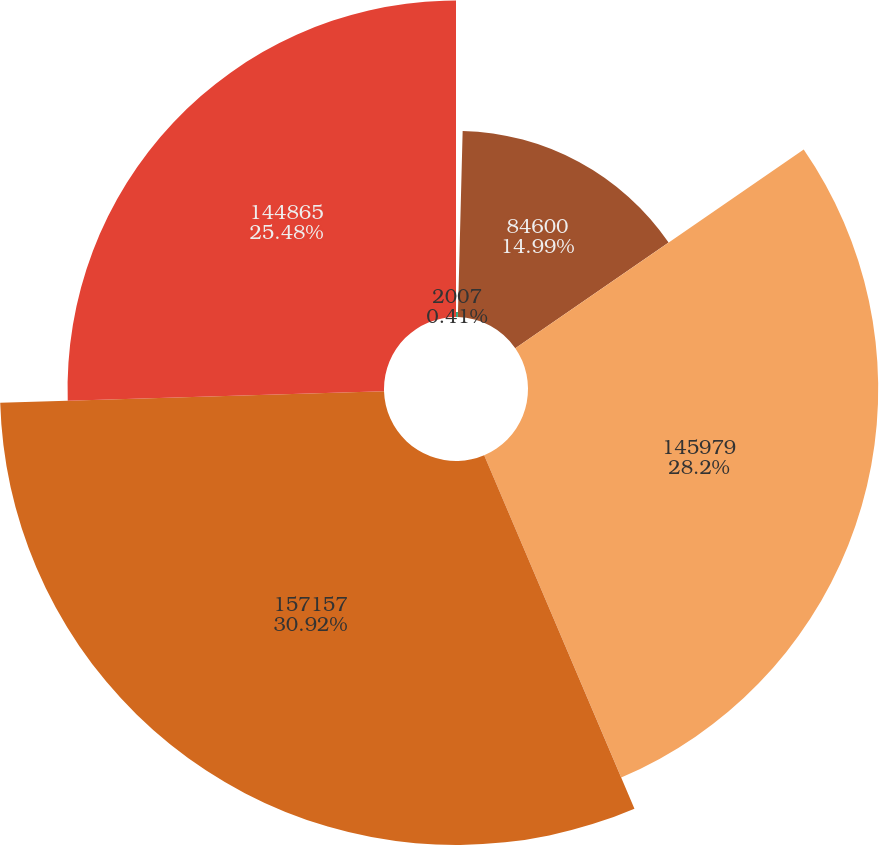Convert chart to OTSL. <chart><loc_0><loc_0><loc_500><loc_500><pie_chart><fcel>2007<fcel>84600<fcel>145979<fcel>157157<fcel>144865<nl><fcel>0.41%<fcel>14.99%<fcel>28.2%<fcel>30.92%<fcel>25.48%<nl></chart> 